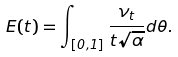<formula> <loc_0><loc_0><loc_500><loc_500>E ( t ) = \int _ { [ 0 , 1 ] } \frac { \nu _ { t } } { t \sqrt { \alpha } } d \theta .</formula> 